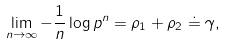<formula> <loc_0><loc_0><loc_500><loc_500>\lim _ { n \rightarrow \infty } - \frac { 1 } { n } \log p ^ { n } = \rho _ { 1 } + \rho _ { 2 } \doteq \gamma ,</formula> 